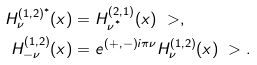<formula> <loc_0><loc_0><loc_500><loc_500>H ^ { ( 1 , 2 ) ^ { * } } _ { \nu } ( x ) = & \ H ^ { ( 2 , 1 ) } _ { \nu ^ { ^ { * } } } ( x ) \ > , \\ H ^ { ( 1 , 2 ) } _ { - \nu } ( x ) = & \ e ^ { ( + , - ) i \pi \nu } H ^ { ( 1 , 2 ) } _ { \nu } ( x ) \ > .</formula> 